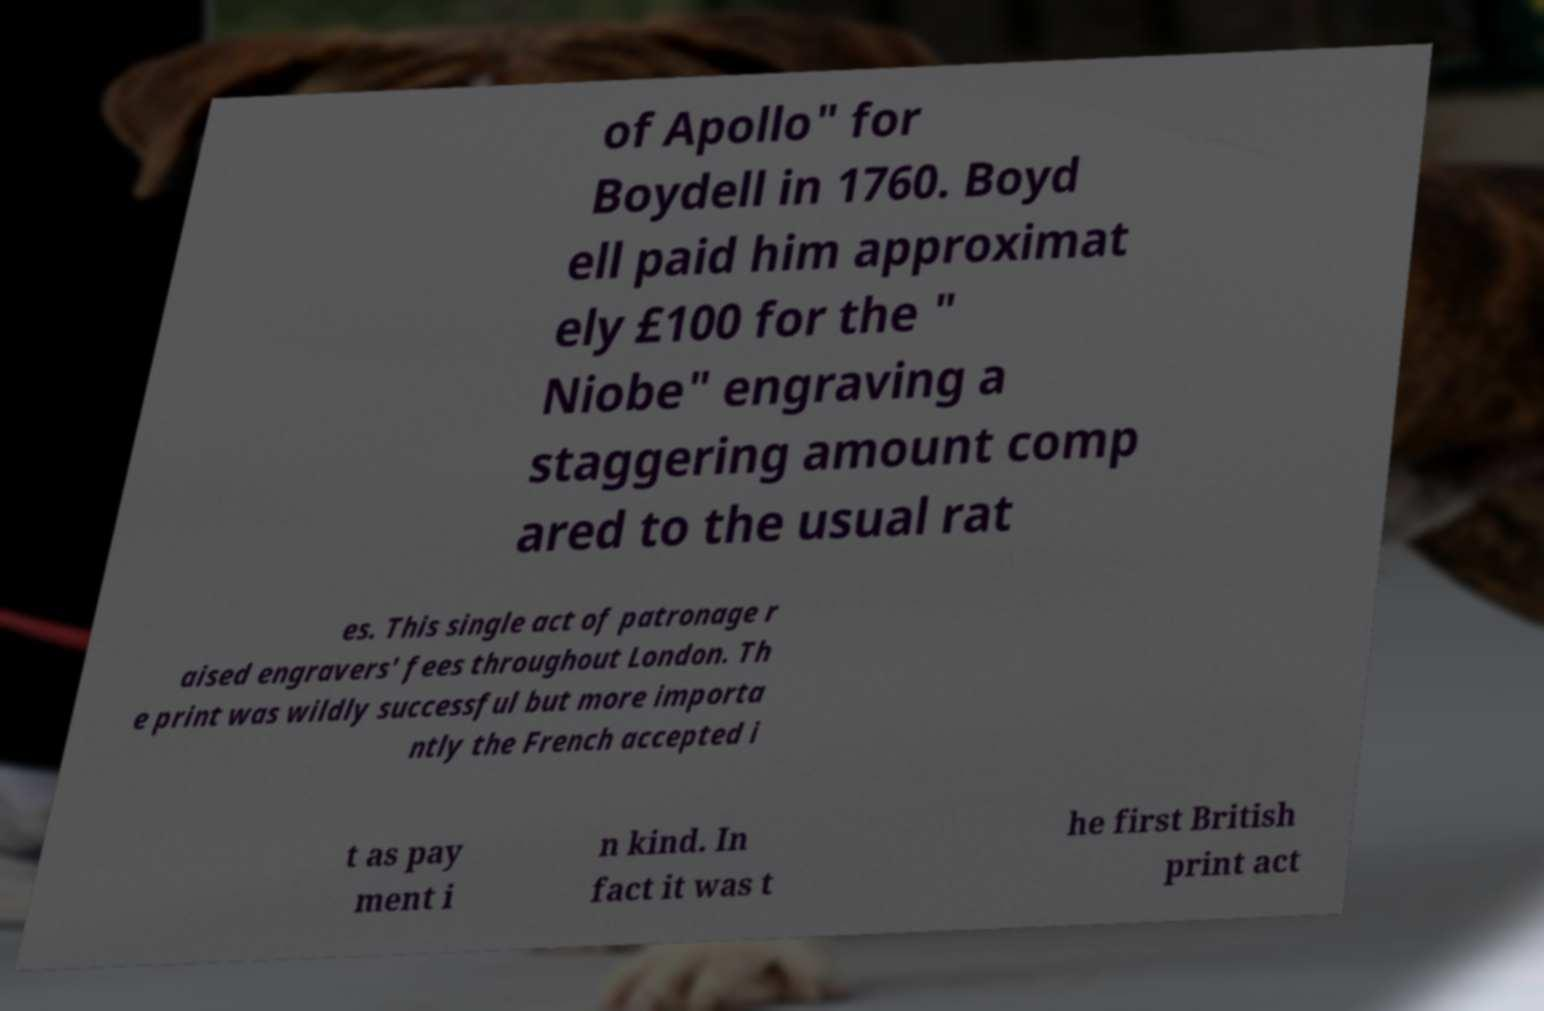There's text embedded in this image that I need extracted. Can you transcribe it verbatim? of Apollo" for Boydell in 1760. Boyd ell paid him approximat ely £100 for the " Niobe" engraving a staggering amount comp ared to the usual rat es. This single act of patronage r aised engravers' fees throughout London. Th e print was wildly successful but more importa ntly the French accepted i t as pay ment i n kind. In fact it was t he first British print act 